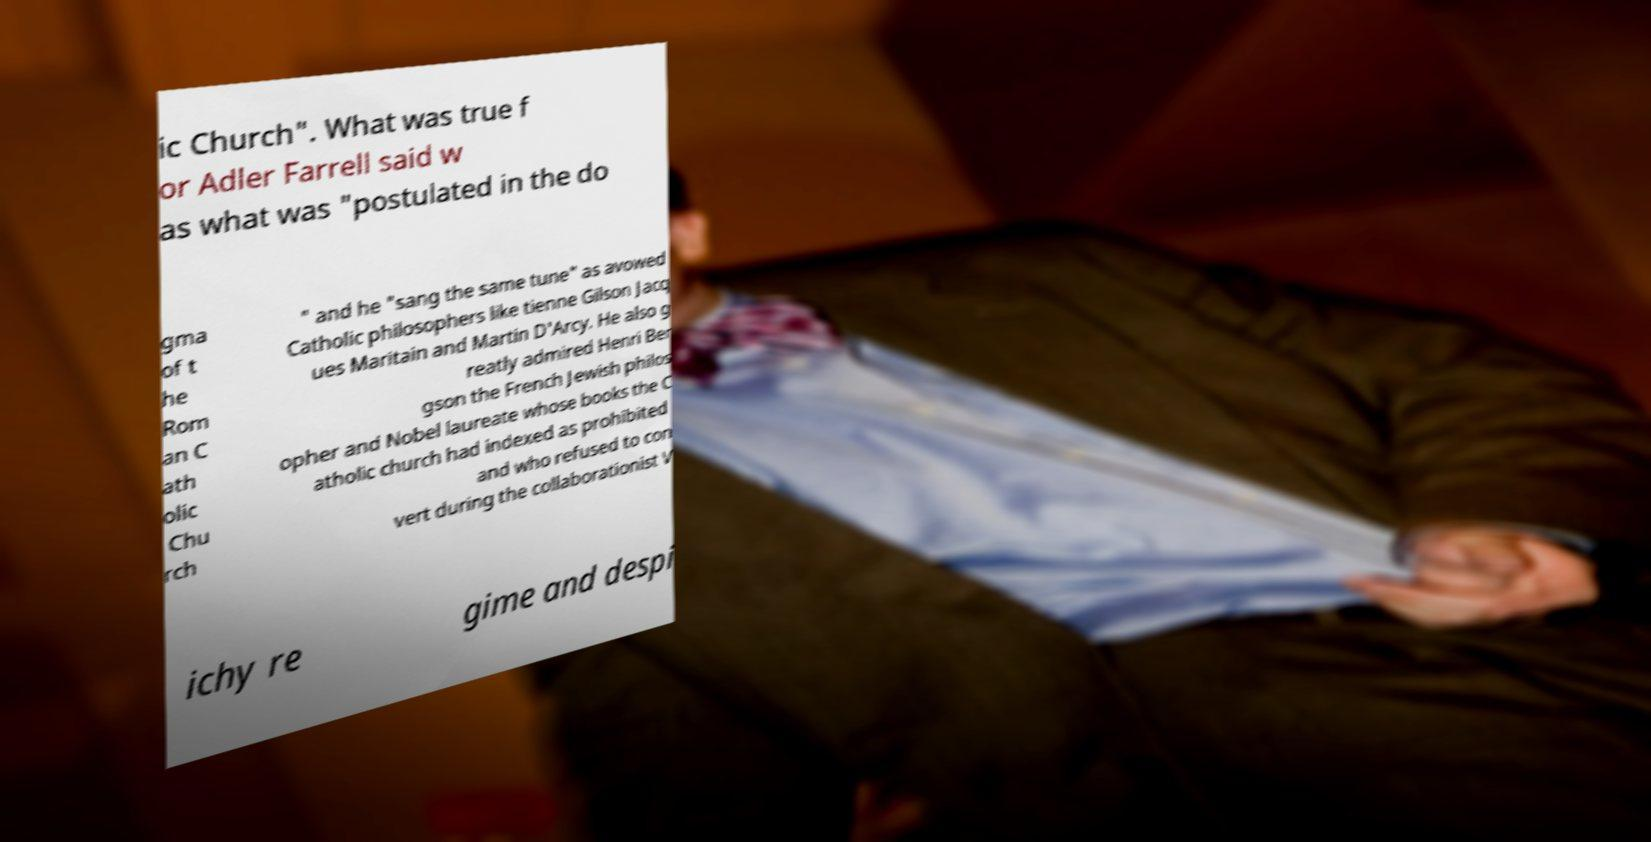There's text embedded in this image that I need extracted. Can you transcribe it verbatim? ic Church". What was true f or Adler Farrell said w as what was "postulated in the do gma of t he Rom an C ath olic Chu rch " and he "sang the same tune" as avowed Catholic philosophers like tienne Gilson Jacq ues Maritain and Martin D'Arcy. He also g reatly admired Henri Ber gson the French Jewish philos opher and Nobel laureate whose books the C atholic church had indexed as prohibited and who refused to con vert during the collaborationist V ichy re gime and despi 